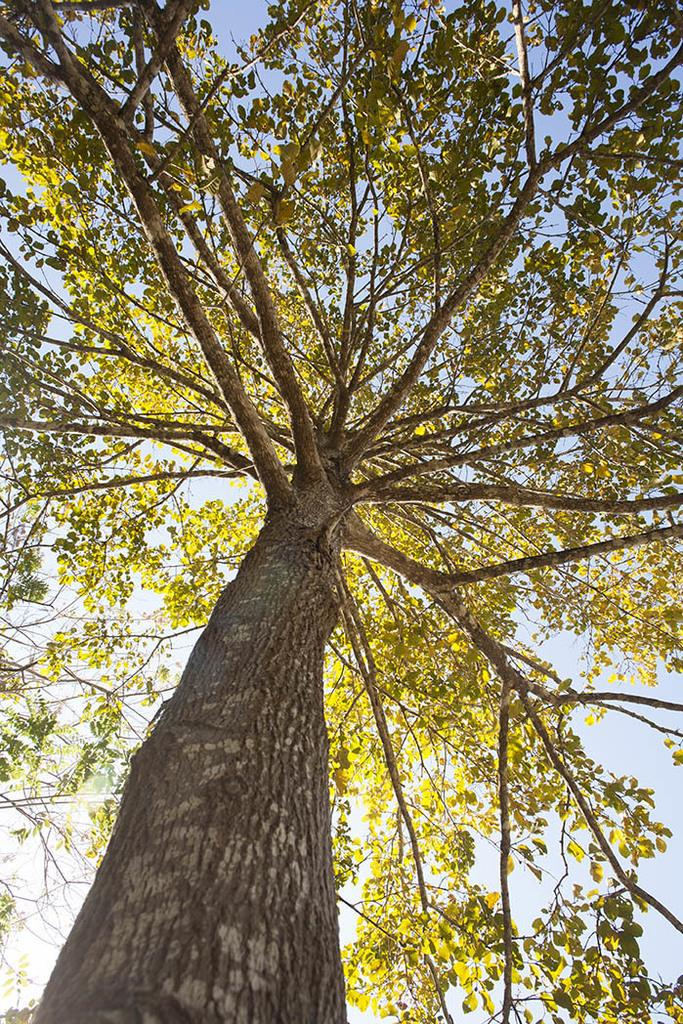What is the main object in the image? There is a tree in the image. What can be seen in the background of the image? The sky is visible in the background of the image. What type of jewel is being used to decorate the tree in the image? There is no jewel present in the image; it features a tree and the sky in the background. 